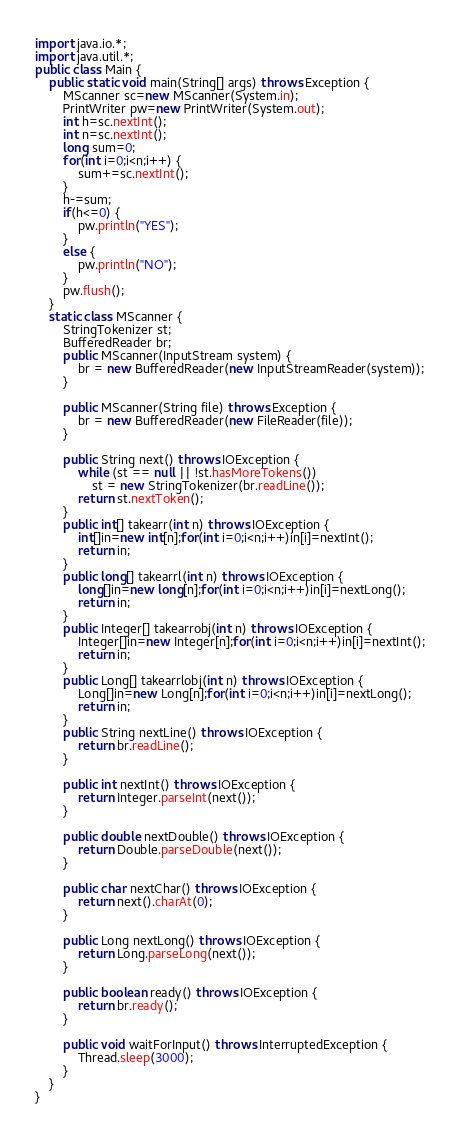Convert code to text. <code><loc_0><loc_0><loc_500><loc_500><_Java_>import java.io.*;
import java.util.*;
public class Main {
	public static void main(String[] args) throws Exception {
		MScanner sc=new MScanner(System.in);
		PrintWriter pw=new PrintWriter(System.out);
		int h=sc.nextInt();
		int n=sc.nextInt();
		long sum=0;
		for(int i=0;i<n;i++) {
			sum+=sc.nextInt();
		}
		h-=sum;
		if(h<=0) {
			pw.println("YES");
		}
		else {
			pw.println("NO");
		}
		pw.flush();
	}
	static class MScanner {
		StringTokenizer st;
		BufferedReader br;
		public MScanner(InputStream system) {
			br = new BufferedReader(new InputStreamReader(system));
		}
 
		public MScanner(String file) throws Exception {
			br = new BufferedReader(new FileReader(file));
		}
 
		public String next() throws IOException {
			while (st == null || !st.hasMoreTokens())
				st = new StringTokenizer(br.readLine());
			return st.nextToken();
		}
		public int[] takearr(int n) throws IOException {
	        int[]in=new int[n];for(int i=0;i<n;i++)in[i]=nextInt();
	        return in;
		}
		public long[] takearrl(int n) throws IOException {
	        long[]in=new long[n];for(int i=0;i<n;i++)in[i]=nextLong();
	        return in;
		}
		public Integer[] takearrobj(int n) throws IOException {
	        Integer[]in=new Integer[n];for(int i=0;i<n;i++)in[i]=nextInt();
	        return in;
		}
		public Long[] takearrlobj(int n) throws IOException {
	        Long[]in=new Long[n];for(int i=0;i<n;i++)in[i]=nextLong();
	        return in;
		}
		public String nextLine() throws IOException {
			return br.readLine();
		}
 
		public int nextInt() throws IOException {
			return Integer.parseInt(next());
		}
 
		public double nextDouble() throws IOException {
			return Double.parseDouble(next());
		}
 
		public char nextChar() throws IOException {
			return next().charAt(0);
		}
 
		public Long nextLong() throws IOException {
			return Long.parseLong(next());
		}
 
		public boolean ready() throws IOException {
			return br.ready();
		}
 
		public void waitForInput() throws InterruptedException {
			Thread.sleep(3000);
		}
	}
}</code> 